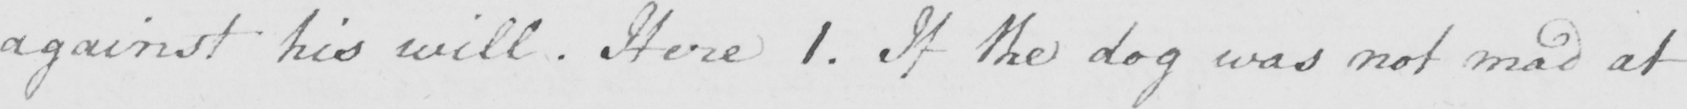What does this handwritten line say? against his will . here 1 . If the dog was not mad at 